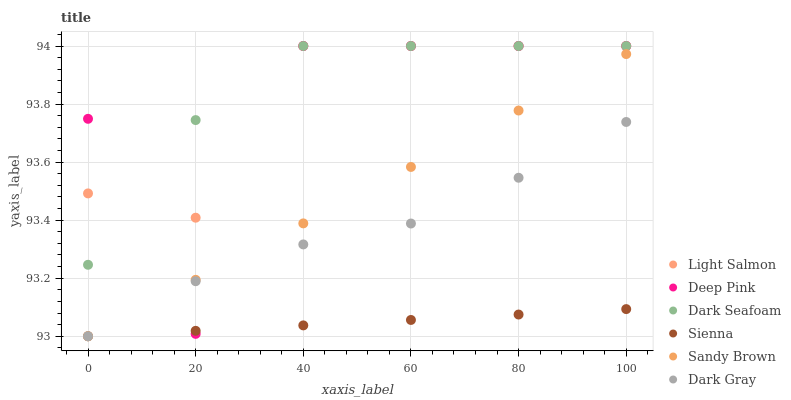Does Sienna have the minimum area under the curve?
Answer yes or no. Yes. Does Dark Seafoam have the maximum area under the curve?
Answer yes or no. Yes. Does Light Salmon have the minimum area under the curve?
Answer yes or no. No. Does Light Salmon have the maximum area under the curve?
Answer yes or no. No. Is Sandy Brown the smoothest?
Answer yes or no. Yes. Is Deep Pink the roughest?
Answer yes or no. Yes. Is Light Salmon the smoothest?
Answer yes or no. No. Is Light Salmon the roughest?
Answer yes or no. No. Does Dark Gray have the lowest value?
Answer yes or no. Yes. Does Deep Pink have the lowest value?
Answer yes or no. No. Does Dark Seafoam have the highest value?
Answer yes or no. Yes. Does Sienna have the highest value?
Answer yes or no. No. Is Dark Gray less than Dark Seafoam?
Answer yes or no. Yes. Is Light Salmon greater than Dark Gray?
Answer yes or no. Yes. Does Dark Gray intersect Sandy Brown?
Answer yes or no. Yes. Is Dark Gray less than Sandy Brown?
Answer yes or no. No. Is Dark Gray greater than Sandy Brown?
Answer yes or no. No. Does Dark Gray intersect Dark Seafoam?
Answer yes or no. No. 